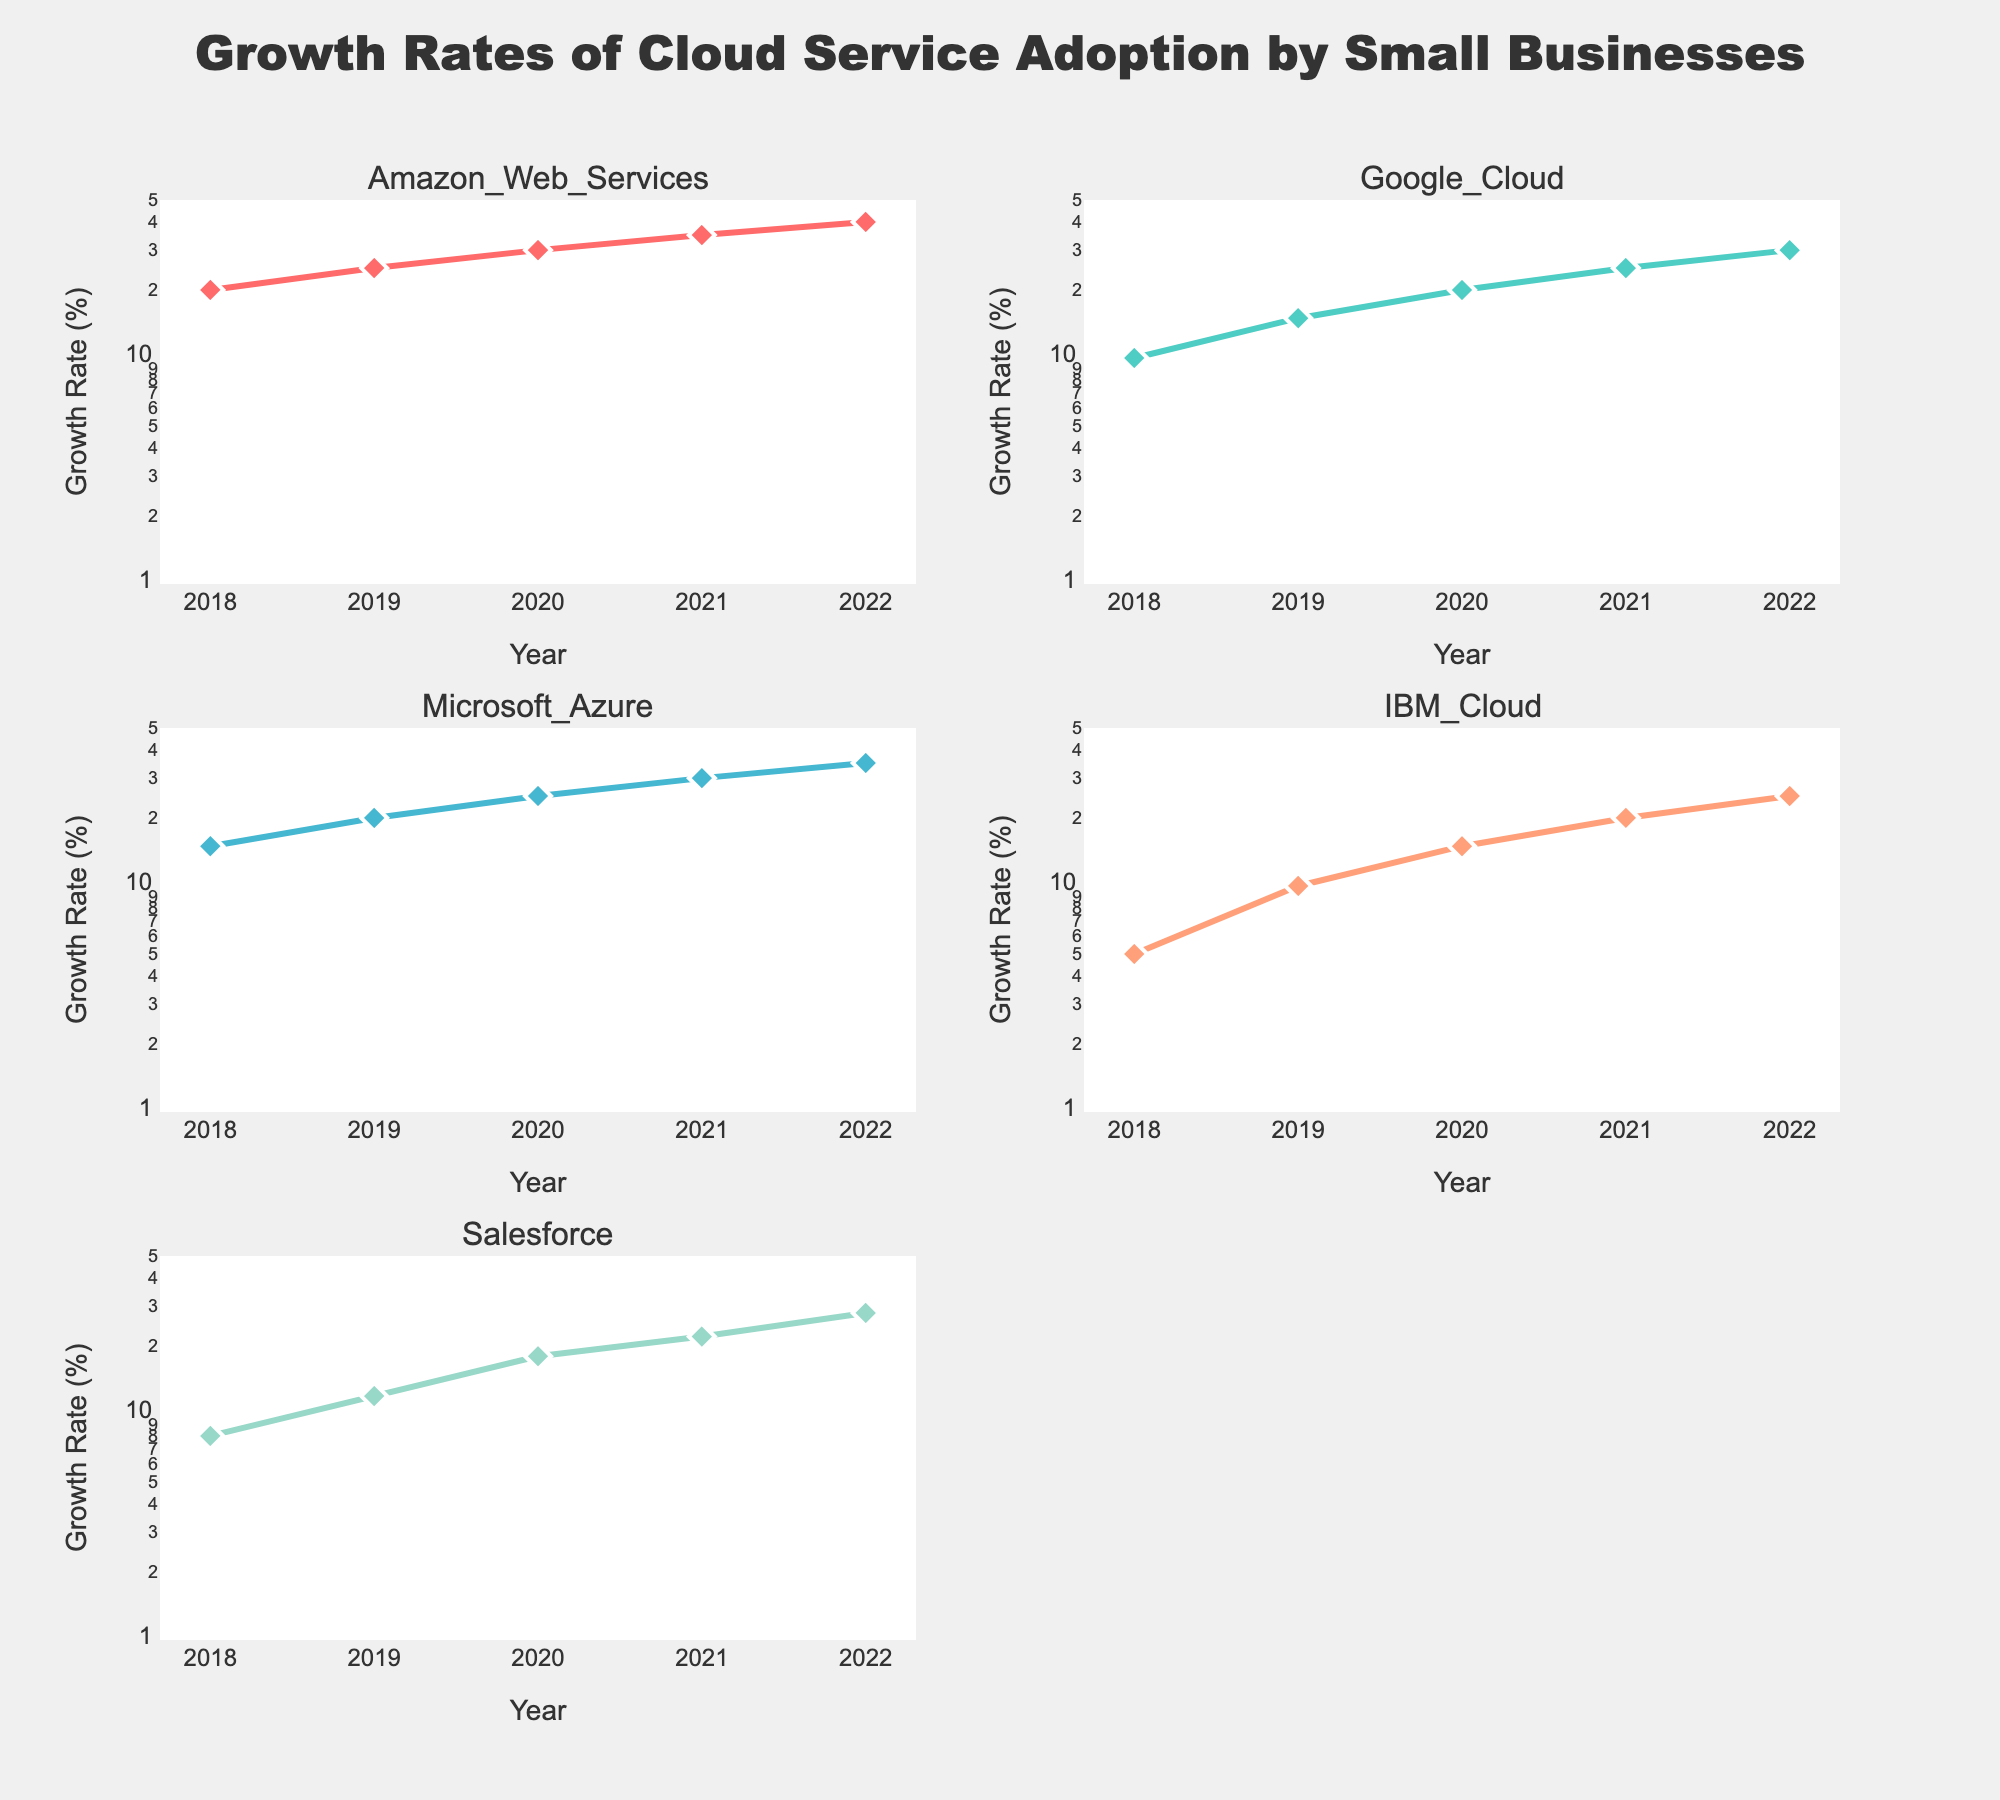What's the title of the figure? The title is positioned at the top center of the figure, where it clearly indicates the subject of the plots.
Answer: Growth Rates of Cloud Service Adoption by Small Businesses What are the cloud services shown in the subplots? The subplot titles provide the names of the cloud services. Each subplot corresponds to a different cloud service, and there are five in total.
Answer: Amazon Web Services, Google Cloud, Microsoft Azure, IBM Cloud, Salesforce What is the highest growth rate percentage observed for Amazon Web Services? By looking at the Amazon Web Services subplot, the highest data point on the y-axis indicates the growth rate percentage.
Answer: 40% Which cloud service had the lowest growth rate percentage in 2018? The 2018 data points for each subplot can be compared to find the smallest value.
Answer: IBM Cloud Between which years did Salesforce show the largest increase in growth rate percentage? By examining the Salesforce subplot, the largest slope is between two consecutive years where the growth rate percentage increased the most.
Answer: 2019 to 2020 How does the growth rate percentage for Microsoft Azure in 2020 compare with Google Cloud in 2020? By checking 2020 data points for both Microsoft Azure and Google Cloud subplots, compare the y-axis values representing growth rates.
Answer: Microsoft Azure is higher Did any cloud service exhibit a consistent linear trend in growth rate percentage over the years? A consistent linear trend would show a straight-line increase in the subplots from 2018 to 2022.
Answer: Yes, Amazon Web Services What is the fastest growth rate increase observed in a single year across all services? Determine the largest single-year increase in growth rate percentage by analyzing yearly increments in each subplot.
Answer: Salesforce from 2019 to 2020 Which two cloud services had the closest growth rate percentages in 2021? Compare the 2021 data points in each subplot to find the two services with the smallest difference.
Answer: Amazon Web Services and Microsoft Azure How does the log scale affect the visualization of growth rates? Logarithmic scale transforms higher values to be more comparable with lower values, making exponential growth patterns easier to observe.
Answer: Makes exponential trends more visible 